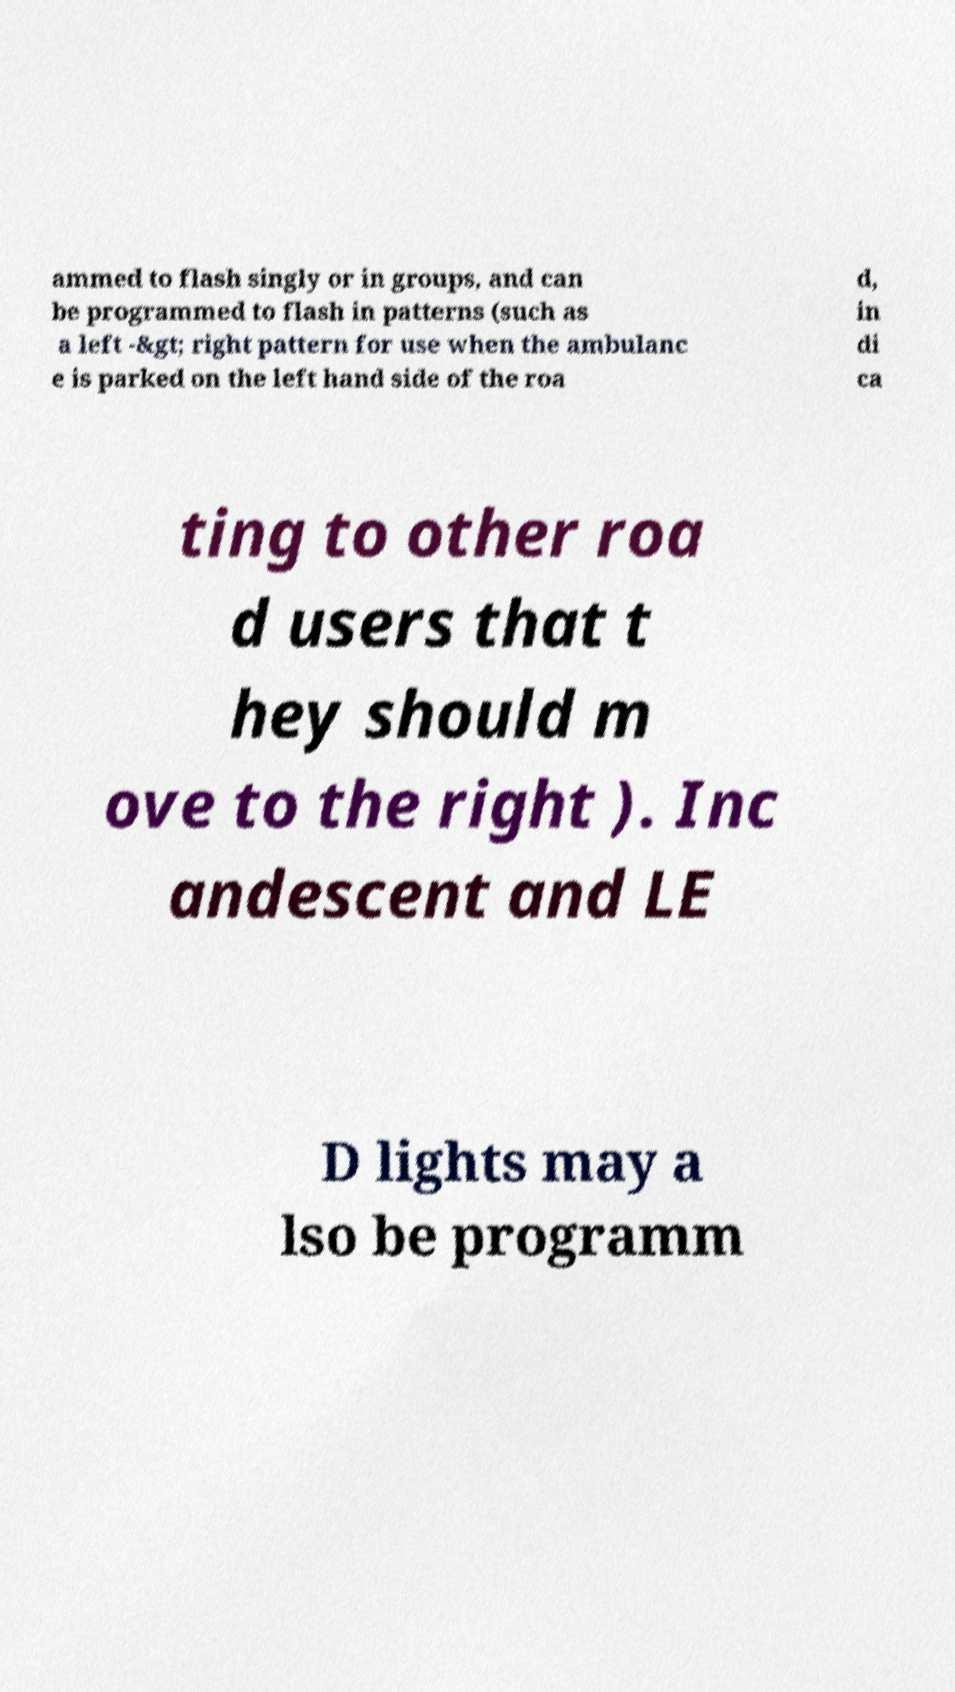Can you read and provide the text displayed in the image?This photo seems to have some interesting text. Can you extract and type it out for me? ammed to flash singly or in groups, and can be programmed to flash in patterns (such as a left -&gt; right pattern for use when the ambulanc e is parked on the left hand side of the roa d, in di ca ting to other roa d users that t hey should m ove to the right ). Inc andescent and LE D lights may a lso be programm 